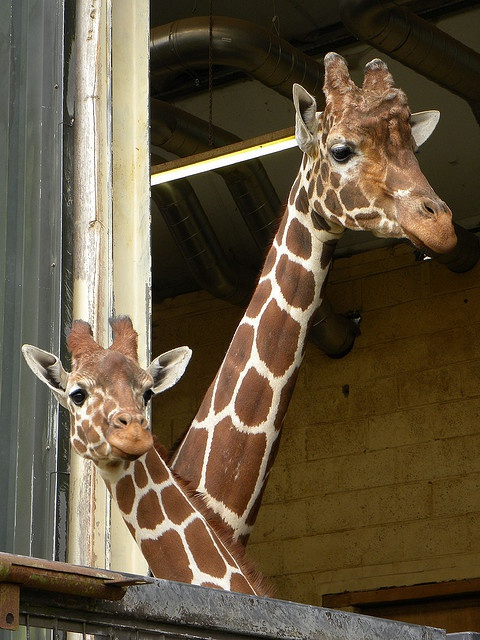Describe the objects in this image and their specific colors. I can see giraffe in gray, maroon, and tan tones and giraffe in gray, maroon, ivory, and tan tones in this image. 